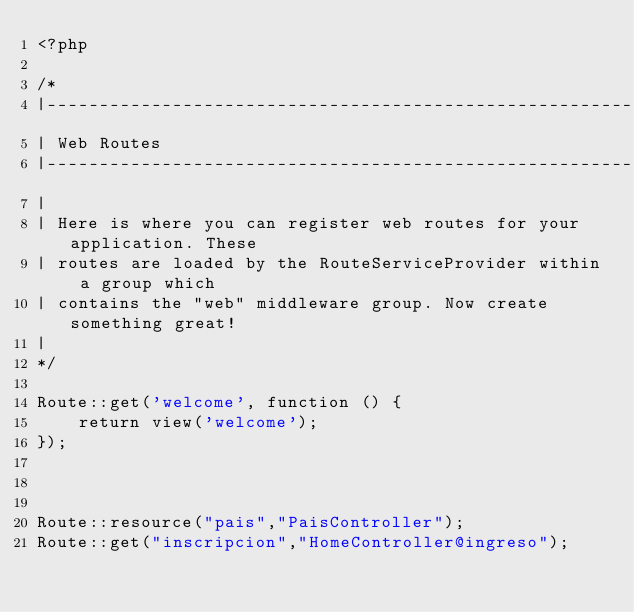<code> <loc_0><loc_0><loc_500><loc_500><_PHP_><?php

/*
|--------------------------------------------------------------------------
| Web Routes
|--------------------------------------------------------------------------
|
| Here is where you can register web routes for your application. These
| routes are loaded by the RouteServiceProvider within a group which
| contains the "web" middleware group. Now create something great!
|
*/

Route::get('welcome', function () {
    return view('welcome');
});



Route::resource("pais","PaisController");
Route::get("inscripcion","HomeController@ingreso");
</code> 